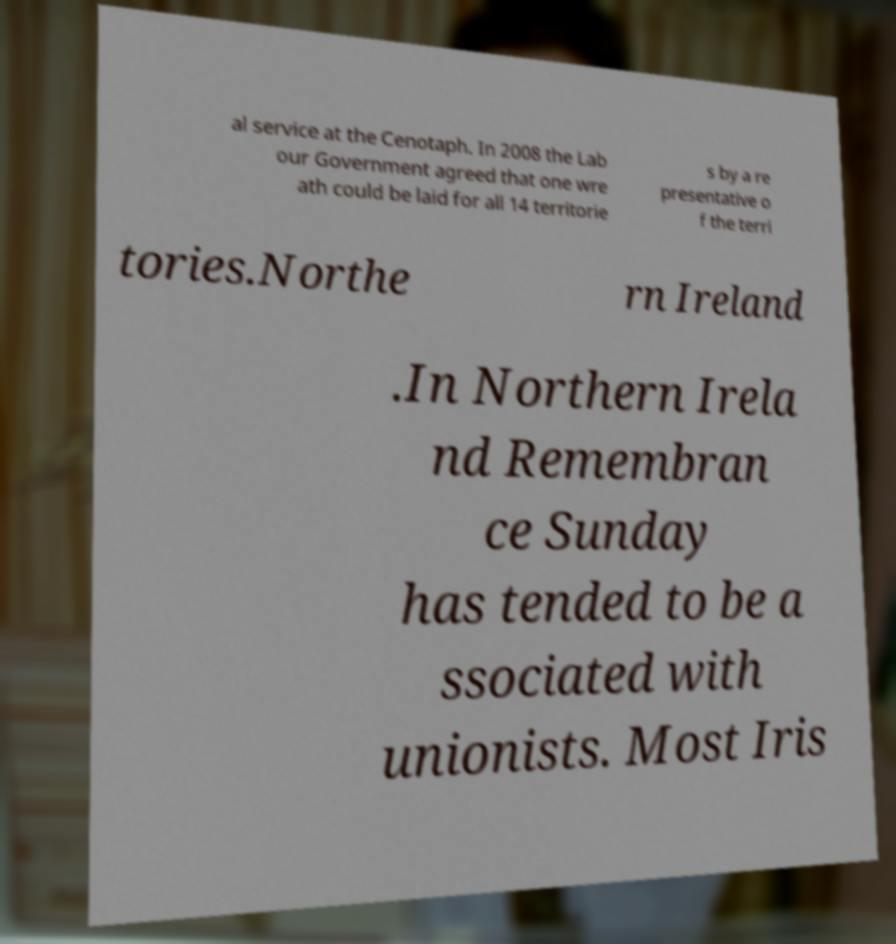Please read and relay the text visible in this image. What does it say? al service at the Cenotaph. In 2008 the Lab our Government agreed that one wre ath could be laid for all 14 territorie s by a re presentative o f the terri tories.Northe rn Ireland .In Northern Irela nd Remembran ce Sunday has tended to be a ssociated with unionists. Most Iris 